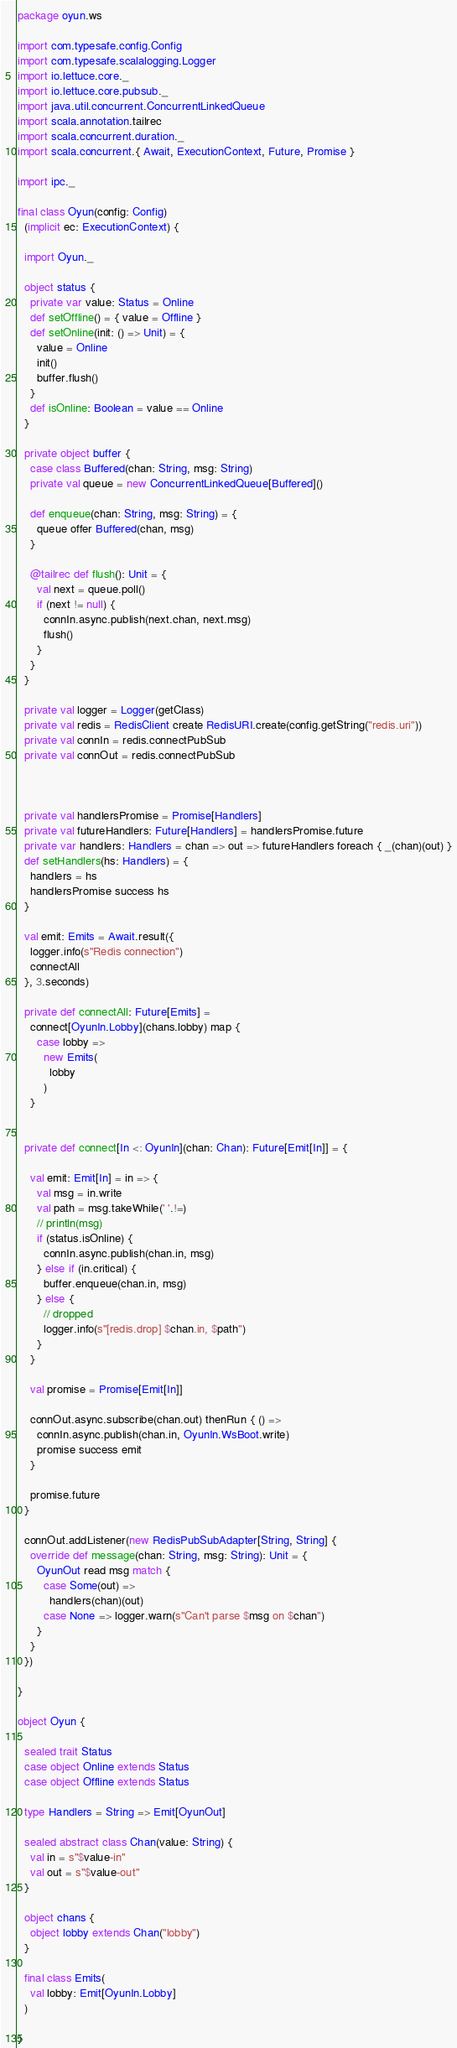Convert code to text. <code><loc_0><loc_0><loc_500><loc_500><_Scala_>package oyun.ws

import com.typesafe.config.Config
import com.typesafe.scalalogging.Logger
import io.lettuce.core._
import io.lettuce.core.pubsub._
import java.util.concurrent.ConcurrentLinkedQueue
import scala.annotation.tailrec
import scala.concurrent.duration._
import scala.concurrent.{ Await, ExecutionContext, Future, Promise }

import ipc._

final class Oyun(config: Config)
  (implicit ec: ExecutionContext) {

  import Oyun._

  object status {
    private var value: Status = Online
    def setOffline() = { value = Offline }
    def setOnline(init: () => Unit) = {
      value = Online
      init()
      buffer.flush()
    }
    def isOnline: Boolean = value == Online
  }

  private object buffer {
    case class Buffered(chan: String, msg: String)
    private val queue = new ConcurrentLinkedQueue[Buffered]()

    def enqueue(chan: String, msg: String) = {
      queue offer Buffered(chan, msg)
    }

    @tailrec def flush(): Unit = {
      val next = queue.poll()
      if (next != null) {
        connIn.async.publish(next.chan, next.msg)
        flush()
      }
    }
  }

  private val logger = Logger(getClass)
  private val redis = RedisClient create RedisURI.create(config.getString("redis.uri"))
  private val connIn = redis.connectPubSub
  private val connOut = redis.connectPubSub



  private val handlersPromise = Promise[Handlers]
  private val futureHandlers: Future[Handlers] = handlersPromise.future
  private var handlers: Handlers = chan => out => futureHandlers foreach { _(chan)(out) }
  def setHandlers(hs: Handlers) = {
    handlers = hs
    handlersPromise success hs
  }

  val emit: Emits = Await.result({
    logger.info(s"Redis connection")
    connectAll
  }, 3.seconds)

  private def connectAll: Future[Emits] =
    connect[OyunIn.Lobby](chans.lobby) map {
      case lobby =>
        new Emits(
          lobby
        )
    }


  private def connect[In <: OyunIn](chan: Chan): Future[Emit[In]] = {

    val emit: Emit[In] = in => {
      val msg = in.write
      val path = msg.takeWhile(' '.!=)
      // println(msg)
      if (status.isOnline) {
        connIn.async.publish(chan.in, msg)
      } else if (in.critical) {
        buffer.enqueue(chan.in, msg)
      } else {
        // dropped
        logger.info(s"[redis.drop] $chan.in, $path")
      }
    }

    val promise = Promise[Emit[In]]

    connOut.async.subscribe(chan.out) thenRun { () =>
      connIn.async.publish(chan.in, OyunIn.WsBoot.write)
      promise success emit
    }

    promise.future
  }
  
  connOut.addListener(new RedisPubSubAdapter[String, String] {
    override def message(chan: String, msg: String): Unit = {
      OyunOut read msg match {
        case Some(out) => 
          handlers(chan)(out)
        case None => logger.warn(s"Can't parse $msg on $chan")
      }
    }
  })

}

object Oyun {

  sealed trait Status
  case object Online extends Status
  case object Offline extends Status

  type Handlers = String => Emit[OyunOut]

  sealed abstract class Chan(value: String) {
    val in = s"$value-in"
    val out = s"$value-out"
  }

  object chans {
    object lobby extends Chan("lobby")
  }

  final class Emits(
    val lobby: Emit[OyunIn.Lobby]
  )
  
}
</code> 